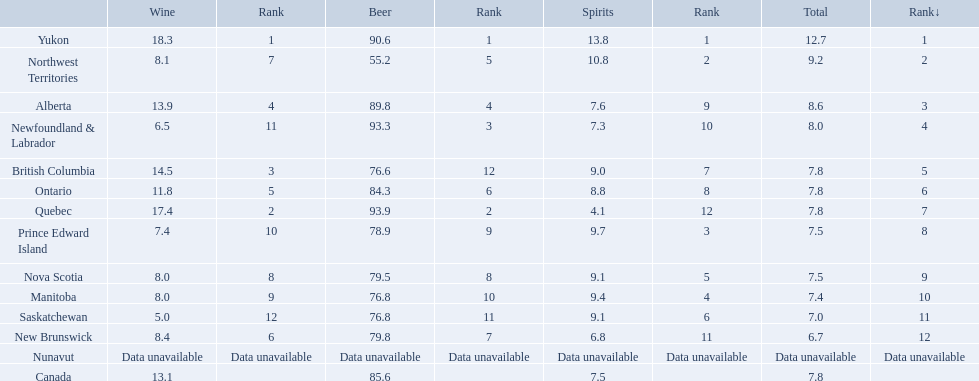Where do people consume the highest average of spirits per year? Yukon. How many liters on average do people here drink per year of spirits? 12.7. Which canadian territory had a beer consumption of 93.9? Quebec. What was their consumption of spirits? 4.1. Which locations consume the same total amount of alcoholic beverages as another location? British Columbia, Ontario, Quebec, Prince Edward Island, Nova Scotia. Which of these consumes more then 80 of beer? Ontario, Quebec. Of those what was the consumption of spirits of the one that consumed the most beer? 4.1. Which spots have a similar total intake of alcoholic beverages as another spot? British Columbia, Ontario, Quebec, Prince Edward Island, Nova Scotia. Which of these consumes in excess of 80 of beer? Ontario, Quebec. Of those, what was the consumption of spirits of the one that consumed the most beer? 4.1. In which canadian area was the beer usage at 93.9? Quebec. What was the intake of alcoholic spirits? 4.1. What is the place with the highest average spirits consumption per person per year? Yukon. How many liters of spirits are typically consumed by an individual in this location annually? 12.7. Where are the locations that have an equal total amount of alcohol consumption as another location? British Columbia, Ontario, Quebec, Prince Edward Island, Nova Scotia. Which of these locations consume over 80 of beer? Ontario, Quebec. Among these, what is the consumption of spirits in the location that consumed the largest amount of beer? 4.1. What are the different canadian regions? Yukon, Northwest Territories, Alberta, Newfoundland & Labrador, British Columbia, Ontario, Quebec, Prince Edward Island, Nova Scotia, Manitoba, Saskatchewan, New Brunswick, Nunavut, Canada. What was the level of spirits consumption? 13.8, 10.8, 7.6, 7.3, 9.0, 8.8, 4.1, 9.7, 9.1, 9.4, 9.1, 6.8, Data unavailable, 7.5. What was the amount of spirits consumed in quebec? 4.1. Can you list all the regions in canada? Yukon, Northwest Territories, Alberta, Newfoundland & Labrador, British Columbia, Ontario, Quebec, Prince Edward Island, Nova Scotia, Manitoba, Saskatchewan, New Brunswick, Nunavut, Canada. Could you parse the entire table? {'header': ['', 'Wine', 'Rank', 'Beer', 'Rank', 'Spirits', 'Rank', 'Total', 'Rank↓'], 'rows': [['Yukon', '18.3', '1', '90.6', '1', '13.8', '1', '12.7', '1'], ['Northwest Territories', '8.1', '7', '55.2', '5', '10.8', '2', '9.2', '2'], ['Alberta', '13.9', '4', '89.8', '4', '7.6', '9', '8.6', '3'], ['Newfoundland & Labrador', '6.5', '11', '93.3', '3', '7.3', '10', '8.0', '4'], ['British Columbia', '14.5', '3', '76.6', '12', '9.0', '7', '7.8', '5'], ['Ontario', '11.8', '5', '84.3', '6', '8.8', '8', '7.8', '6'], ['Quebec', '17.4', '2', '93.9', '2', '4.1', '12', '7.8', '7'], ['Prince Edward Island', '7.4', '10', '78.9', '9', '9.7', '3', '7.5', '8'], ['Nova Scotia', '8.0', '8', '79.5', '8', '9.1', '5', '7.5', '9'], ['Manitoba', '8.0', '9', '76.8', '10', '9.4', '4', '7.4', '10'], ['Saskatchewan', '5.0', '12', '76.8', '11', '9.1', '6', '7.0', '11'], ['New Brunswick', '8.4', '6', '79.8', '7', '6.8', '11', '6.7', '12'], ['Nunavut', 'Data unavailable', 'Data unavailable', 'Data unavailable', 'Data unavailable', 'Data unavailable', 'Data unavailable', 'Data unavailable', 'Data unavailable'], ['Canada', '13.1', '', '85.6', '', '7.5', '', '7.8', '']]} What was the overall consumption of spirits? 13.8, 10.8, 7.6, 7.3, 9.0, 8.8, 4.1, 9.7, 9.1, 9.4, 9.1, 6.8, Data unavailable, 7.5. How much spirits were consumed in quebec? 4.1. 